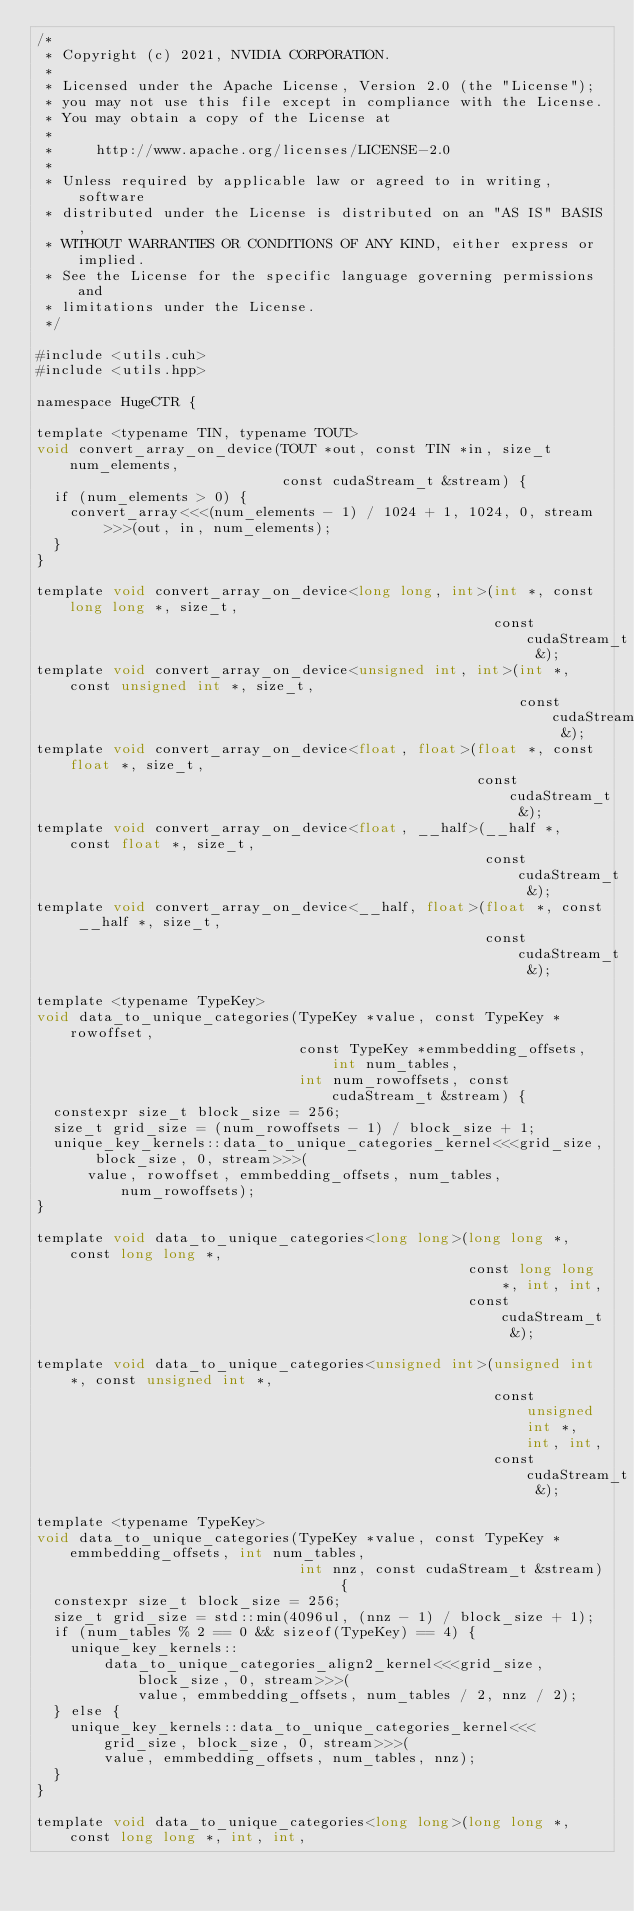Convert code to text. <code><loc_0><loc_0><loc_500><loc_500><_Cuda_>/*
 * Copyright (c) 2021, NVIDIA CORPORATION.
 *
 * Licensed under the Apache License, Version 2.0 (the "License");
 * you may not use this file except in compliance with the License.
 * You may obtain a copy of the License at
 *
 *     http://www.apache.org/licenses/LICENSE-2.0
 *
 * Unless required by applicable law or agreed to in writing, software
 * distributed under the License is distributed on an "AS IS" BASIS,
 * WITHOUT WARRANTIES OR CONDITIONS OF ANY KIND, either express or implied.
 * See the License for the specific language governing permissions and
 * limitations under the License.
 */

#include <utils.cuh>
#include <utils.hpp>

namespace HugeCTR {

template <typename TIN, typename TOUT>
void convert_array_on_device(TOUT *out, const TIN *in, size_t num_elements,
                             const cudaStream_t &stream) {
  if (num_elements > 0) {
    convert_array<<<(num_elements - 1) / 1024 + 1, 1024, 0, stream>>>(out, in, num_elements);
  }
}

template void convert_array_on_device<long long, int>(int *, const long long *, size_t,
                                                      const cudaStream_t &);
template void convert_array_on_device<unsigned int, int>(int *, const unsigned int *, size_t,
                                                         const cudaStream_t &);
template void convert_array_on_device<float, float>(float *, const float *, size_t,
                                                    const cudaStream_t &);
template void convert_array_on_device<float, __half>(__half *, const float *, size_t,
                                                     const cudaStream_t &);
template void convert_array_on_device<__half, float>(float *, const __half *, size_t,
                                                     const cudaStream_t &);

template <typename TypeKey>
void data_to_unique_categories(TypeKey *value, const TypeKey *rowoffset,
                               const TypeKey *emmbedding_offsets, int num_tables,
                               int num_rowoffsets, const cudaStream_t &stream) {
  constexpr size_t block_size = 256;
  size_t grid_size = (num_rowoffsets - 1) / block_size + 1;
  unique_key_kernels::data_to_unique_categories_kernel<<<grid_size, block_size, 0, stream>>>(
      value, rowoffset, emmbedding_offsets, num_tables, num_rowoffsets);
}

template void data_to_unique_categories<long long>(long long *, const long long *,
                                                   const long long *, int, int,
                                                   const cudaStream_t &);

template void data_to_unique_categories<unsigned int>(unsigned int *, const unsigned int *,
                                                      const unsigned int *, int, int,
                                                      const cudaStream_t &);

template <typename TypeKey>
void data_to_unique_categories(TypeKey *value, const TypeKey *emmbedding_offsets, int num_tables,
                               int nnz, const cudaStream_t &stream) {
  constexpr size_t block_size = 256;
  size_t grid_size = std::min(4096ul, (nnz - 1) / block_size + 1);
  if (num_tables % 2 == 0 && sizeof(TypeKey) == 4) {
    unique_key_kernels::
        data_to_unique_categories_align2_kernel<<<grid_size, block_size, 0, stream>>>(
            value, emmbedding_offsets, num_tables / 2, nnz / 2);
  } else {
    unique_key_kernels::data_to_unique_categories_kernel<<<grid_size, block_size, 0, stream>>>(
        value, emmbedding_offsets, num_tables, nnz);
  }
}

template void data_to_unique_categories<long long>(long long *, const long long *, int, int,</code> 